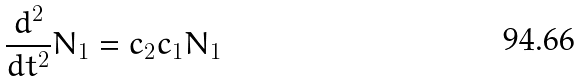<formula> <loc_0><loc_0><loc_500><loc_500>\frac { d ^ { 2 } } { d t ^ { 2 } } N _ { 1 } = c _ { 2 } c _ { 1 } N _ { 1 }</formula> 